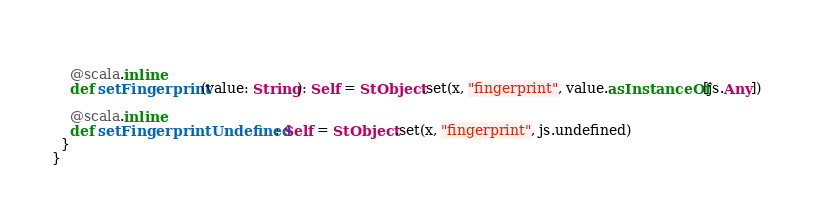<code> <loc_0><loc_0><loc_500><loc_500><_Scala_>    
    @scala.inline
    def setFingerprint(value: String): Self = StObject.set(x, "fingerprint", value.asInstanceOf[js.Any])
    
    @scala.inline
    def setFingerprintUndefined: Self = StObject.set(x, "fingerprint", js.undefined)
  }
}
</code> 